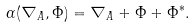<formula> <loc_0><loc_0><loc_500><loc_500>\alpha ( \nabla _ { A } , \Phi ) = \nabla _ { A } + \Phi + \Phi ^ { * } .</formula> 